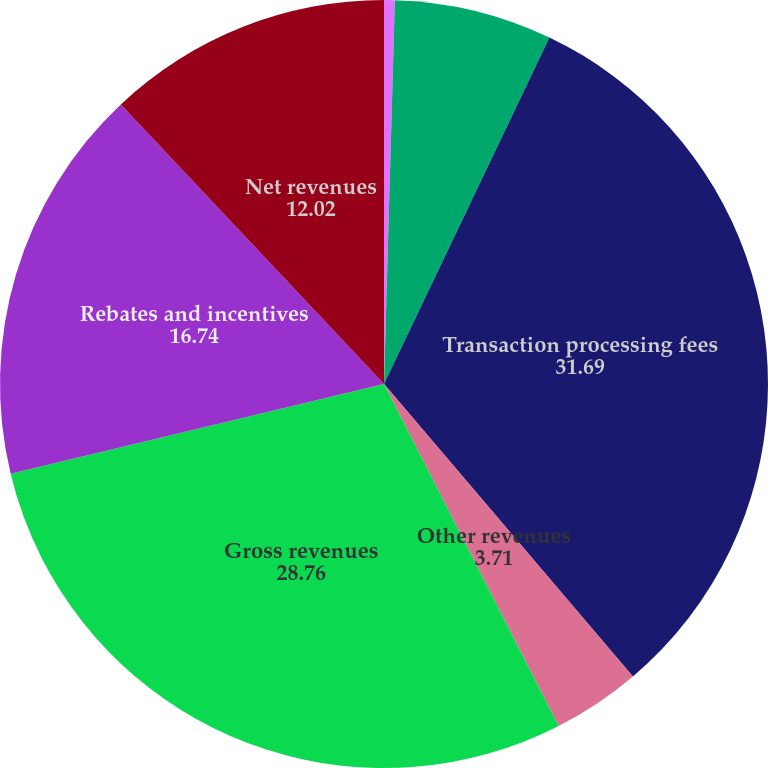Convert chart. <chart><loc_0><loc_0><loc_500><loc_500><pie_chart><fcel>Domestic assessments<fcel>Cross-border volume fees<fcel>Transaction processing fees<fcel>Other revenues<fcel>Gross revenues<fcel>Rebates and incentives<fcel>Net revenues<nl><fcel>0.45%<fcel>6.64%<fcel>31.69%<fcel>3.71%<fcel>28.76%<fcel>16.74%<fcel>12.02%<nl></chart> 